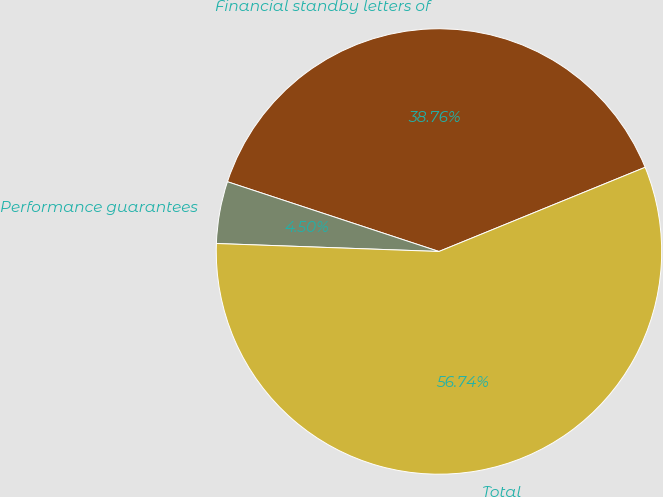Convert chart. <chart><loc_0><loc_0><loc_500><loc_500><pie_chart><fcel>Financial standby letters of<fcel>Performance guarantees<fcel>Total<nl><fcel>38.76%<fcel>4.5%<fcel>56.74%<nl></chart> 